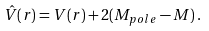<formula> <loc_0><loc_0><loc_500><loc_500>\hat { V } ( r ) = V ( r ) + 2 ( M _ { p o l e } - M ) \, .</formula> 